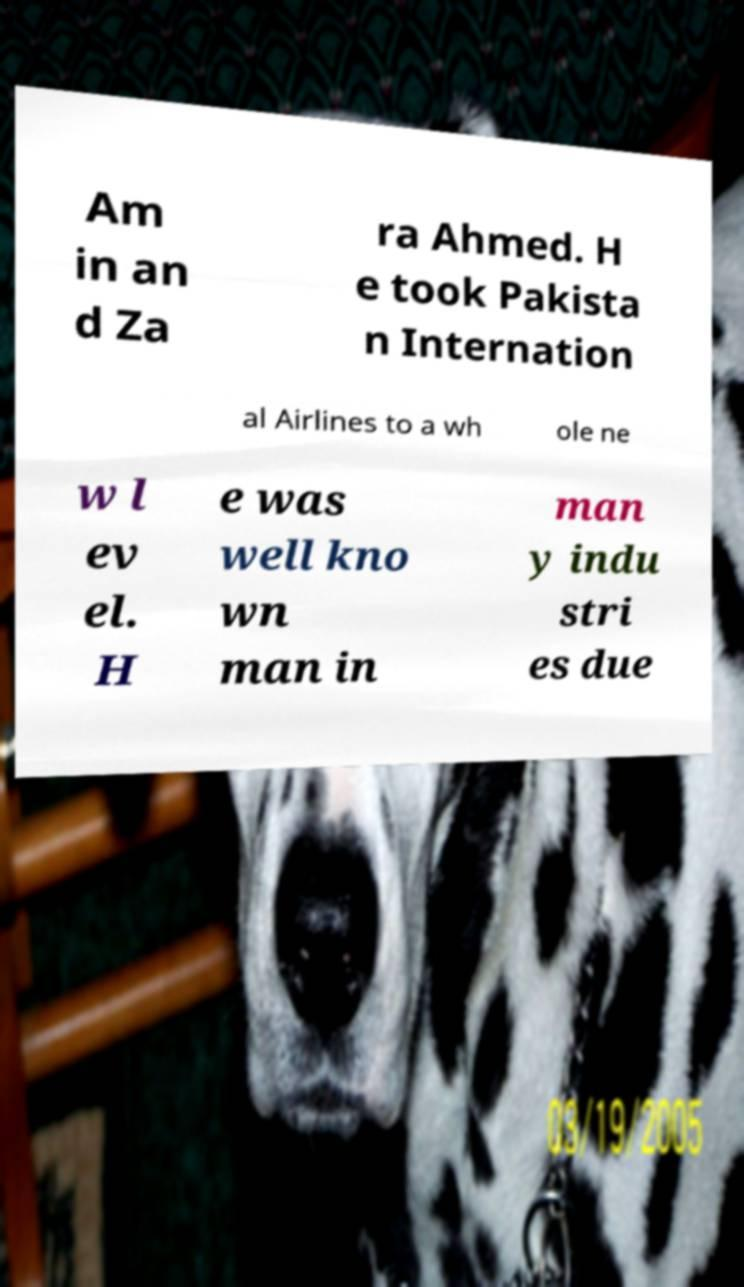What messages or text are displayed in this image? I need them in a readable, typed format. Am in an d Za ra Ahmed. H e took Pakista n Internation al Airlines to a wh ole ne w l ev el. H e was well kno wn man in man y indu stri es due 